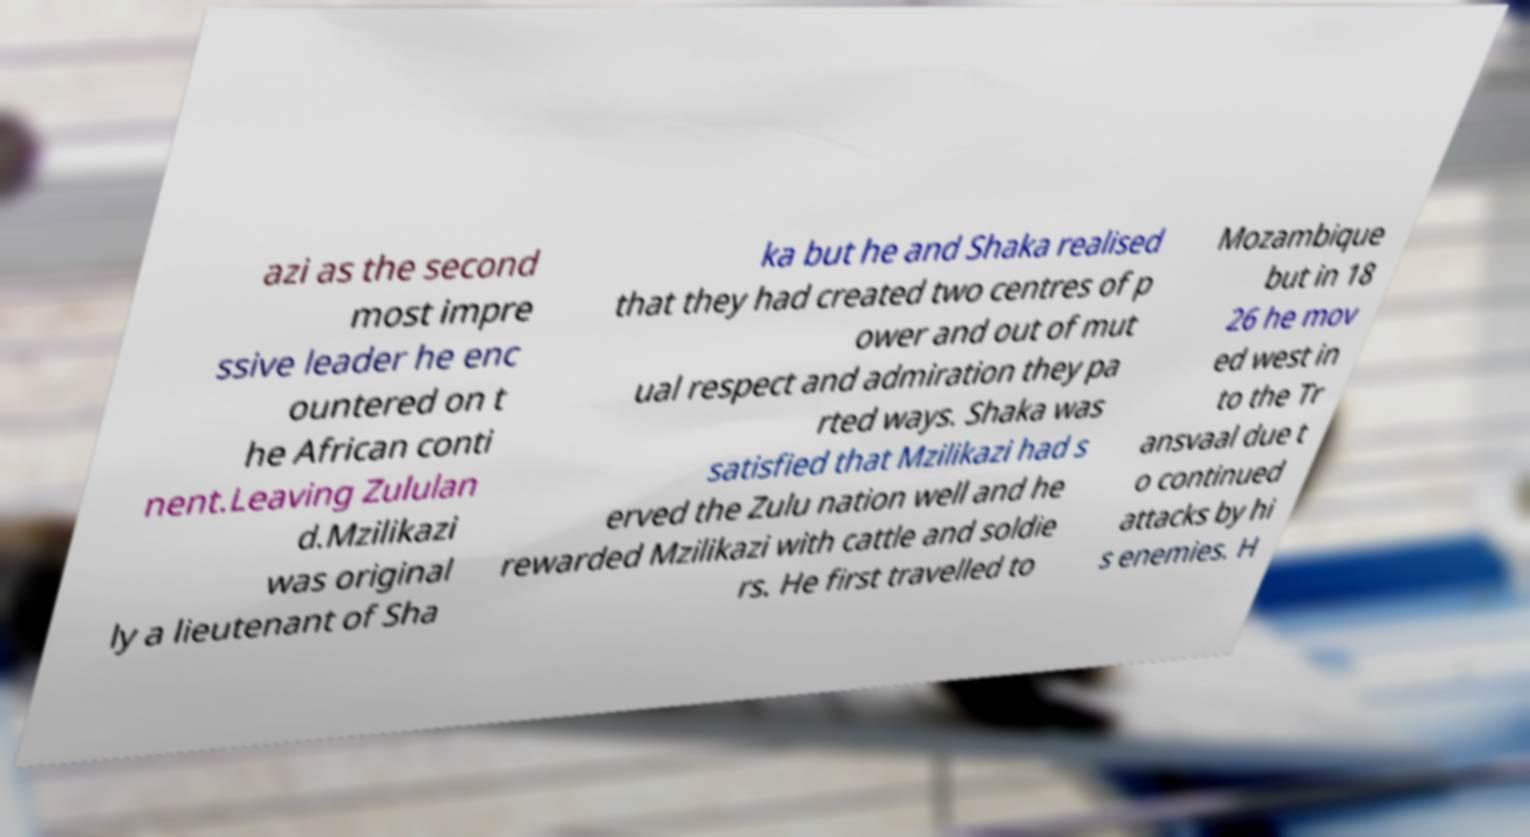Please read and relay the text visible in this image. What does it say? azi as the second most impre ssive leader he enc ountered on t he African conti nent.Leaving Zululan d.Mzilikazi was original ly a lieutenant of Sha ka but he and Shaka realised that they had created two centres of p ower and out of mut ual respect and admiration they pa rted ways. Shaka was satisfied that Mzilikazi had s erved the Zulu nation well and he rewarded Mzilikazi with cattle and soldie rs. He first travelled to Mozambique but in 18 26 he mov ed west in to the Tr ansvaal due t o continued attacks by hi s enemies. H 